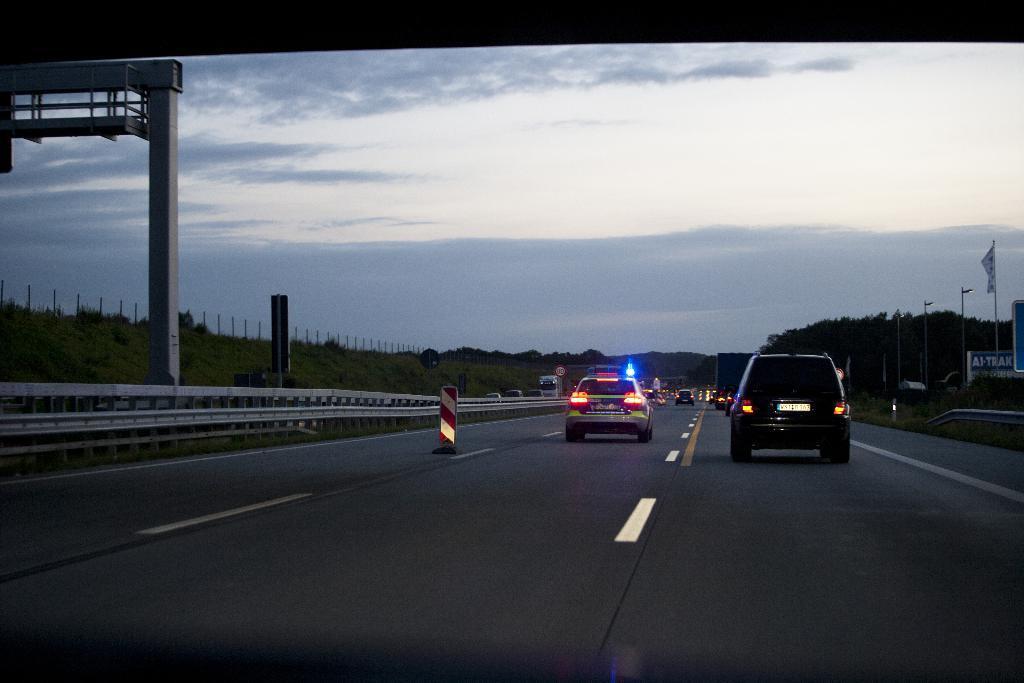How would you summarize this image in a sentence or two? In this image there is a road in the bottom of this image and there are some cars on this road. There are some trees in the background. There is a Fencing wall on the left side of this image. There are some flags on the right side of this image. There is a sky on the top of this image. There is an iron object is kept on the top left side of this image. 